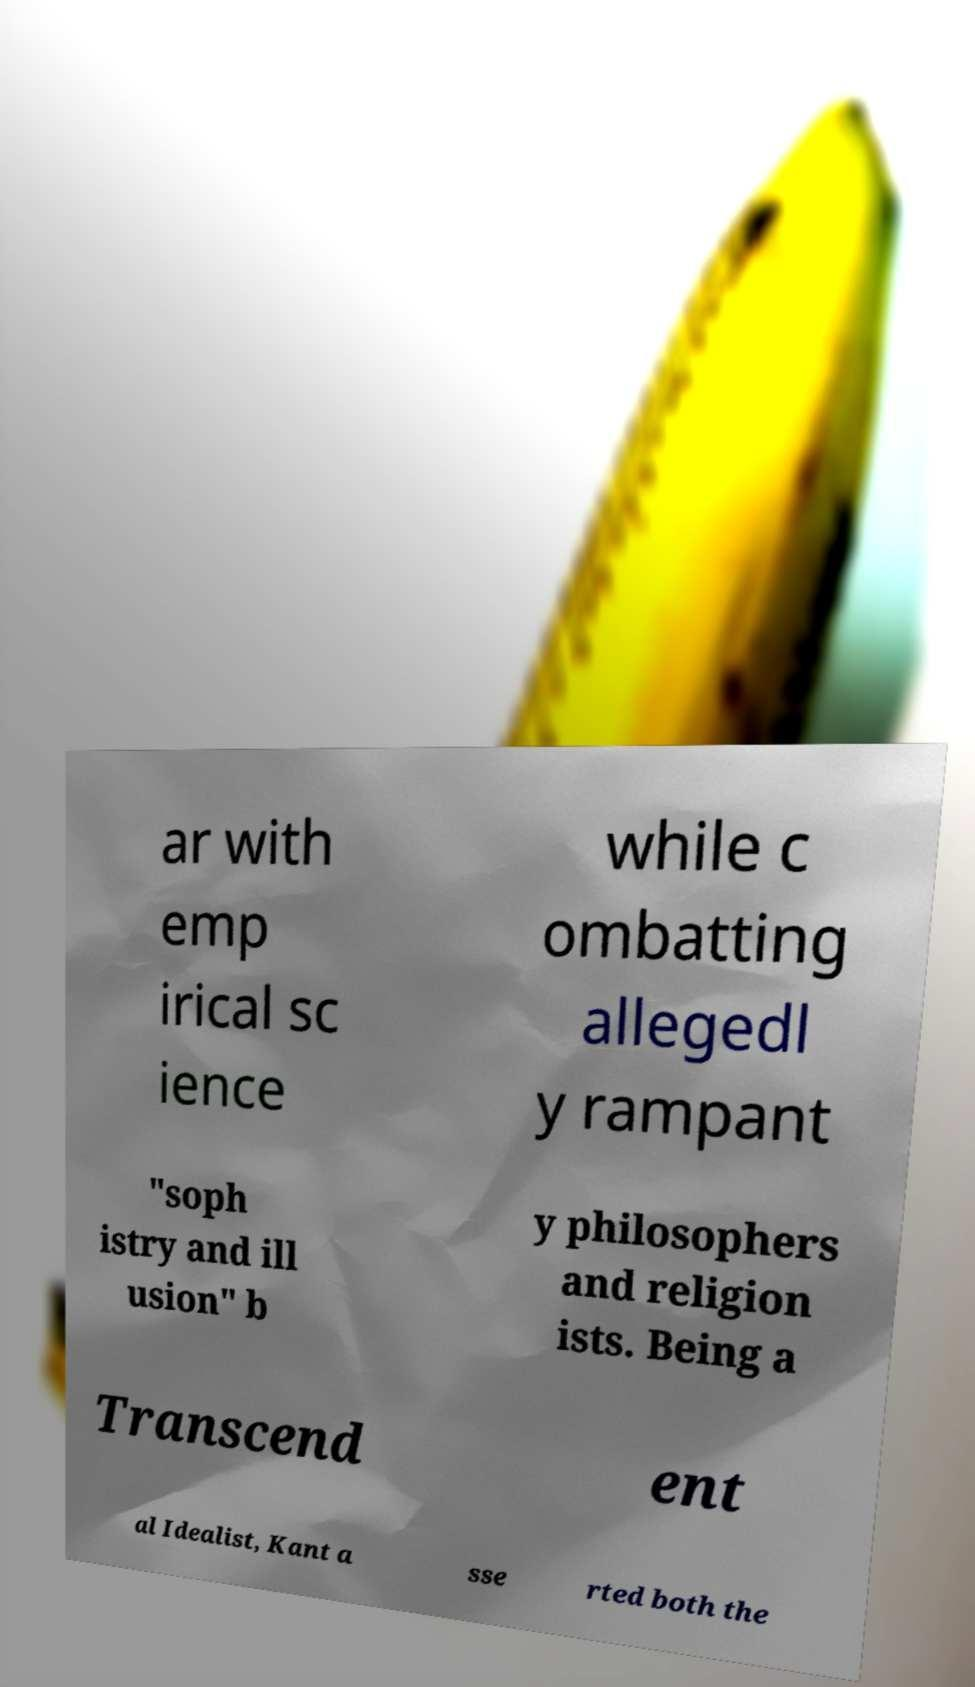Can you accurately transcribe the text from the provided image for me? ar with emp irical sc ience while c ombatting allegedl y rampant "soph istry and ill usion" b y philosophers and religion ists. Being a Transcend ent al Idealist, Kant a sse rted both the 